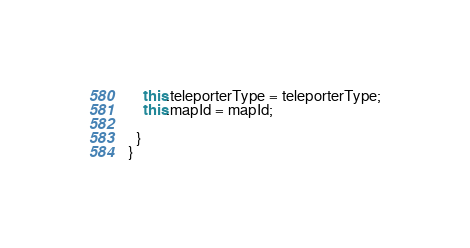<code> <loc_0><loc_0><loc_500><loc_500><_TypeScript_>    this.teleporterType = teleporterType;
    this.mapId = mapId;

  }
}
</code> 